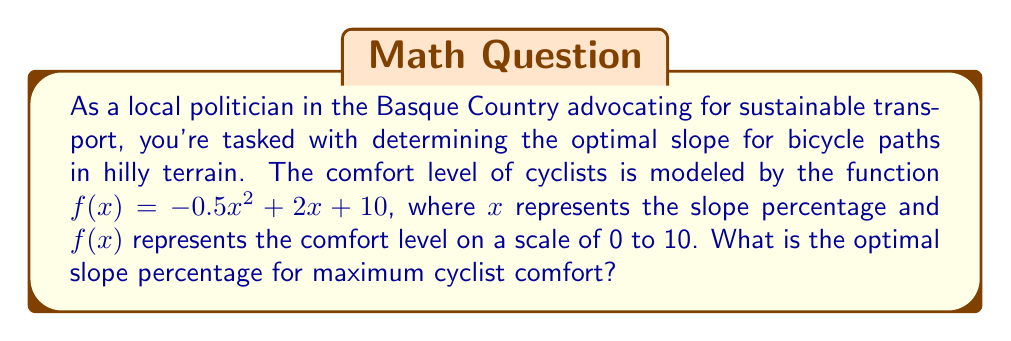Help me with this question. To find the optimal slope percentage for maximum cyclist comfort, we need to find the maximum value of the function $f(x) = -0.5x^2 + 2x + 10$. This can be done by finding the critical point where the derivative of the function equals zero.

Step 1: Find the derivative of $f(x)$.
$$f'(x) = -x + 2$$

Step 2: Set the derivative equal to zero and solve for $x$.
$$-x + 2 = 0$$
$$-x = -2$$
$$x = 2$$

Step 3: Verify that this critical point is a maximum by checking the second derivative.
$$f''(x) = -1$$
Since $f''(x)$ is negative, the critical point is indeed a maximum.

Step 4: Interpret the result.
The optimal slope percentage for maximum cyclist comfort is 2%.

To express this as a decimal for the final answer, we divide by 100:
$$2\% = \frac{2}{100} = 0.02$$
Answer: 0.02 